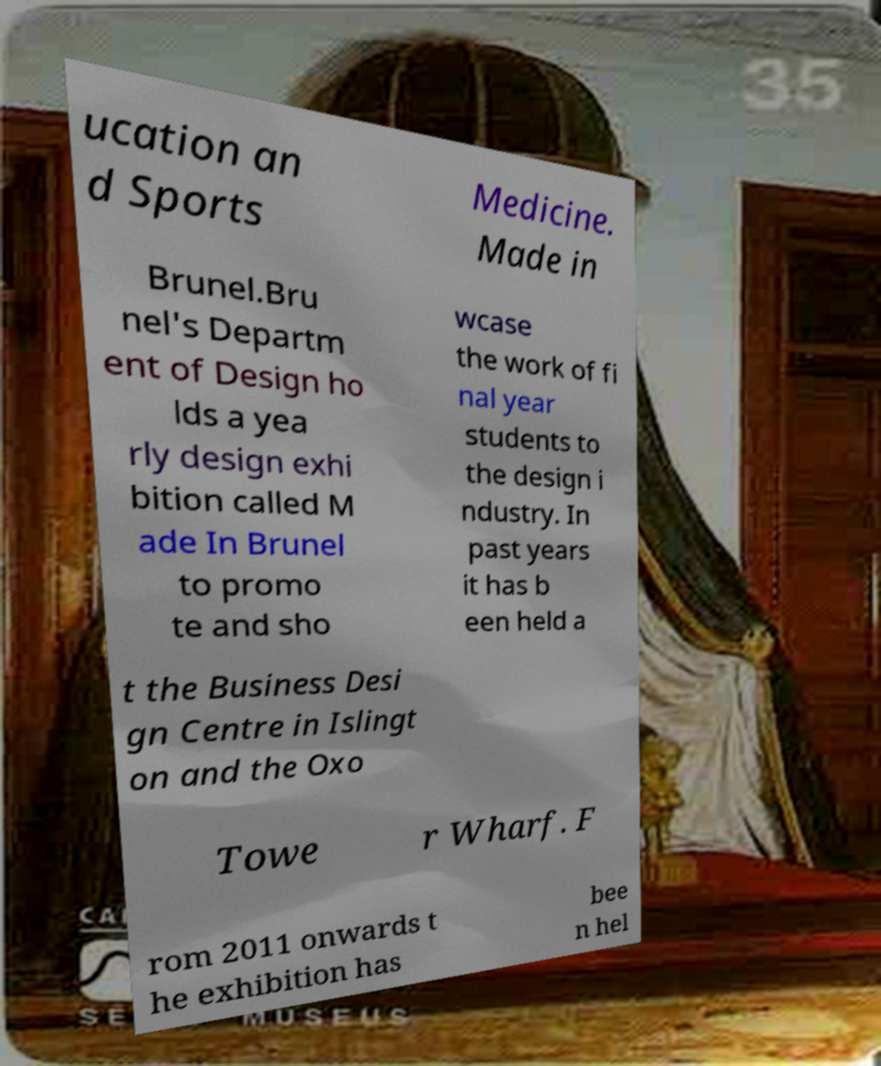I need the written content from this picture converted into text. Can you do that? ucation an d Sports Medicine. Made in Brunel.Bru nel's Departm ent of Design ho lds a yea rly design exhi bition called M ade In Brunel to promo te and sho wcase the work of fi nal year students to the design i ndustry. In past years it has b een held a t the Business Desi gn Centre in Islingt on and the Oxo Towe r Wharf. F rom 2011 onwards t he exhibition has bee n hel 